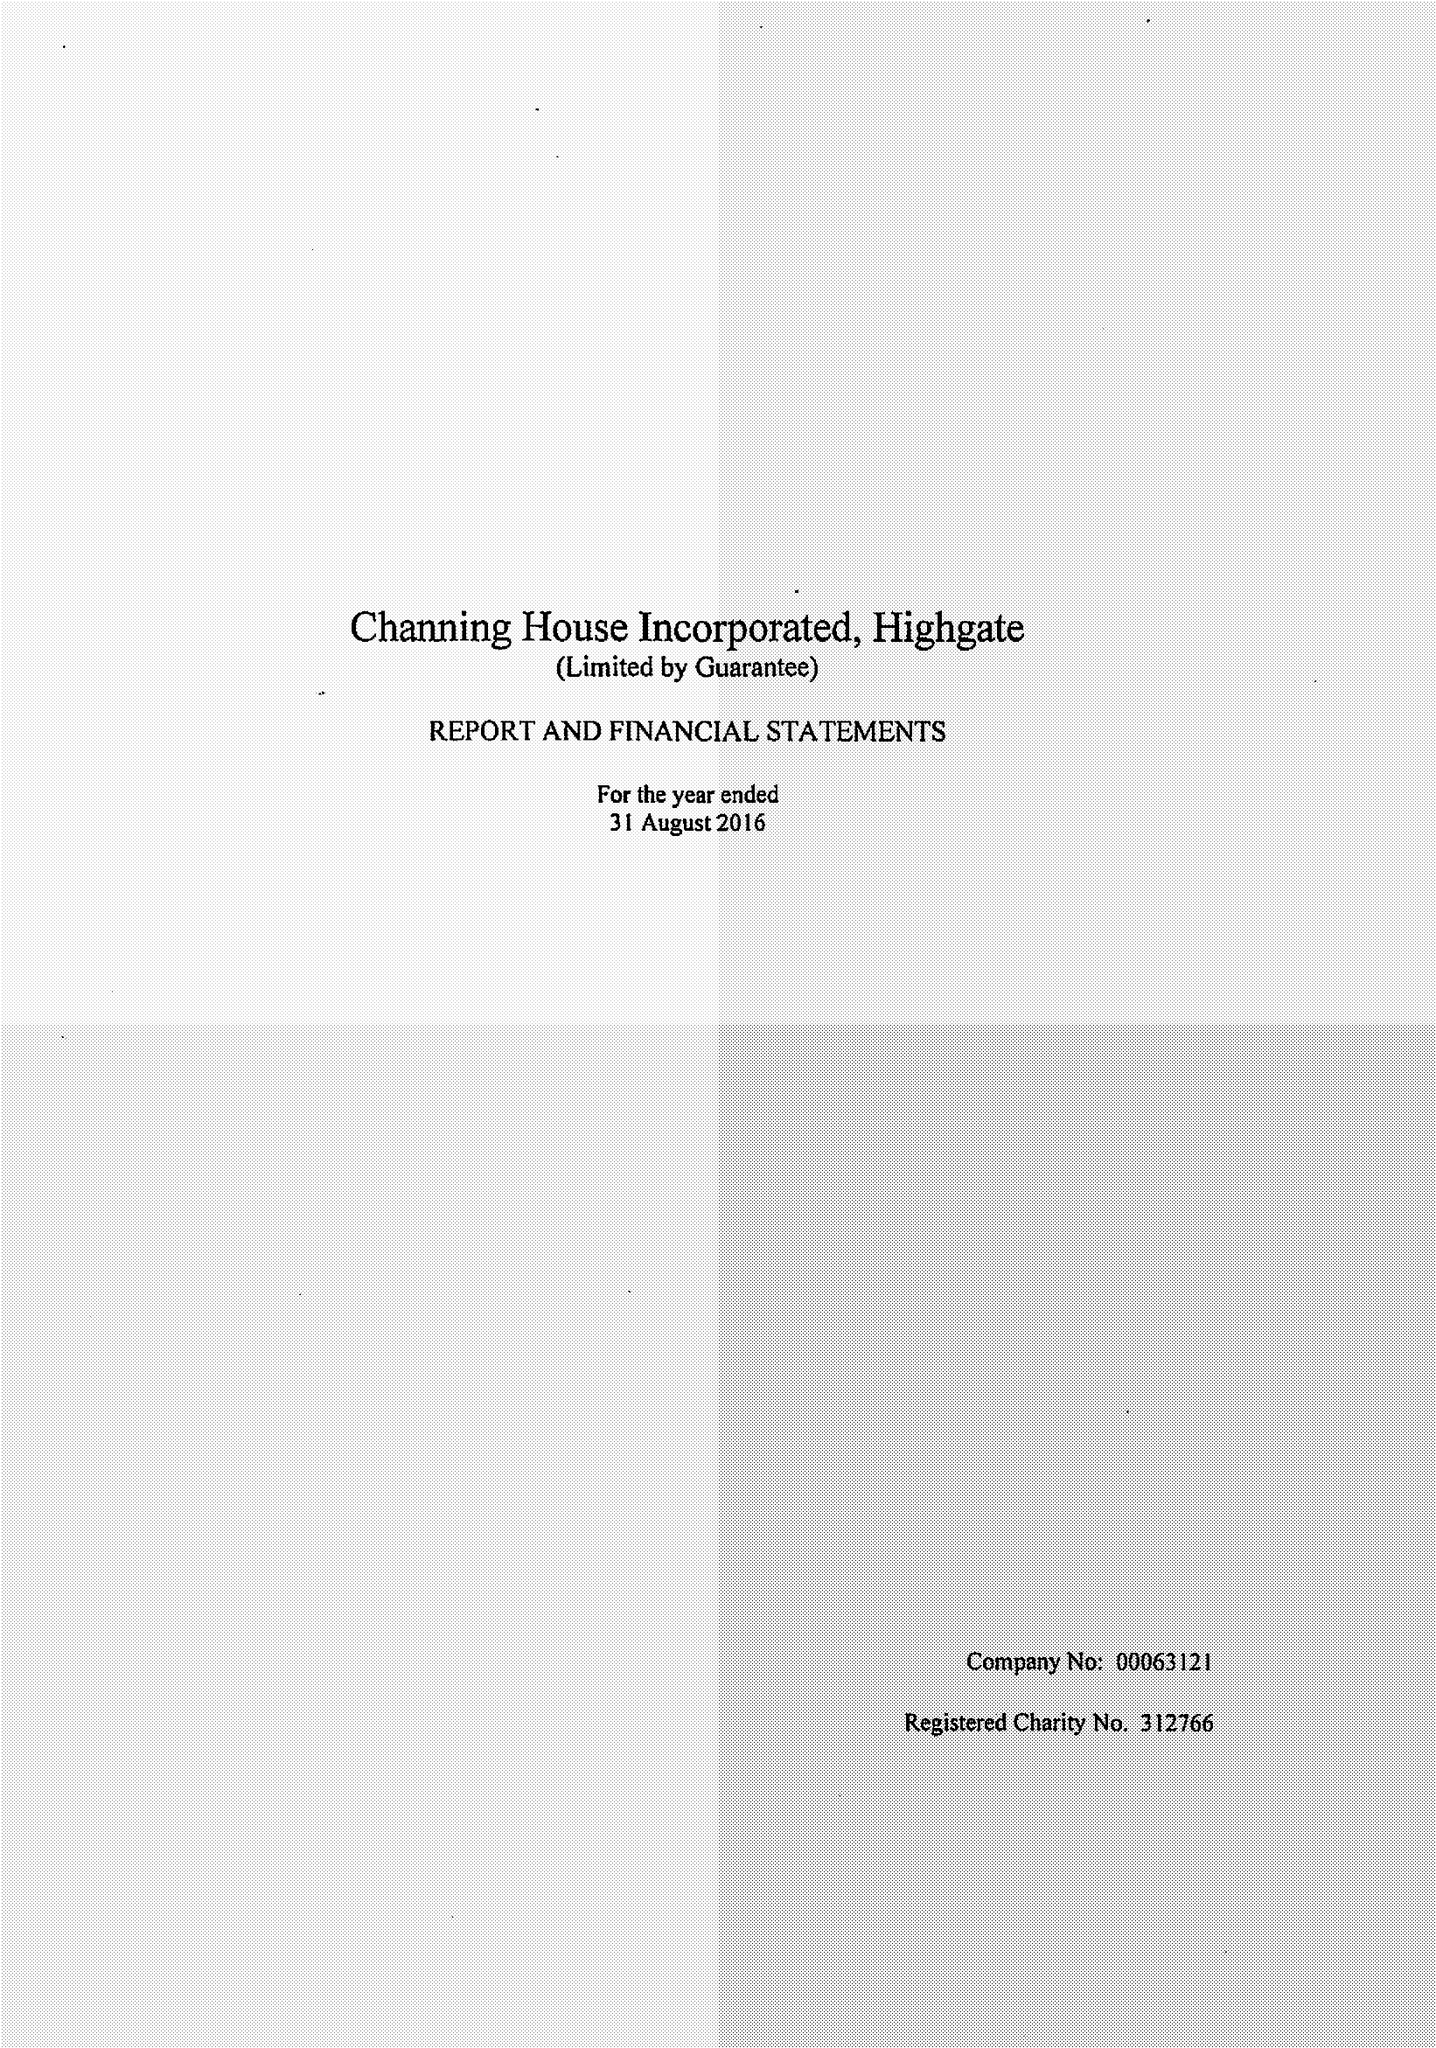What is the value for the charity_number?
Answer the question using a single word or phrase. 312766 